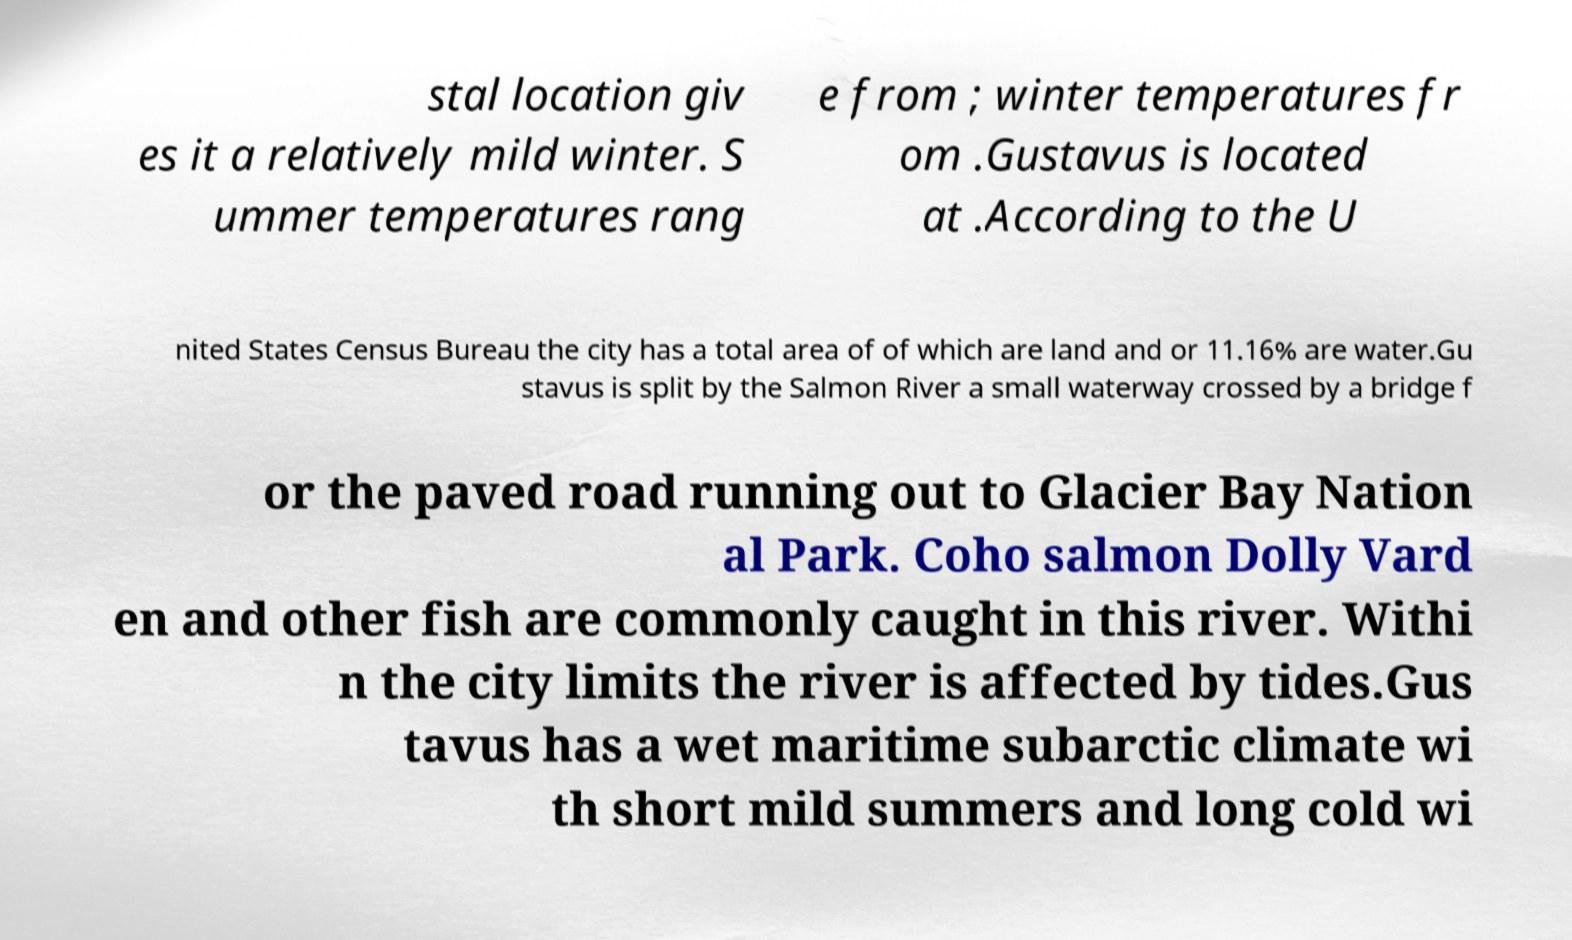Could you extract and type out the text from this image? stal location giv es it a relatively mild winter. S ummer temperatures rang e from ; winter temperatures fr om .Gustavus is located at .According to the U nited States Census Bureau the city has a total area of of which are land and or 11.16% are water.Gu stavus is split by the Salmon River a small waterway crossed by a bridge f or the paved road running out to Glacier Bay Nation al Park. Coho salmon Dolly Vard en and other fish are commonly caught in this river. Withi n the city limits the river is affected by tides.Gus tavus has a wet maritime subarctic climate wi th short mild summers and long cold wi 